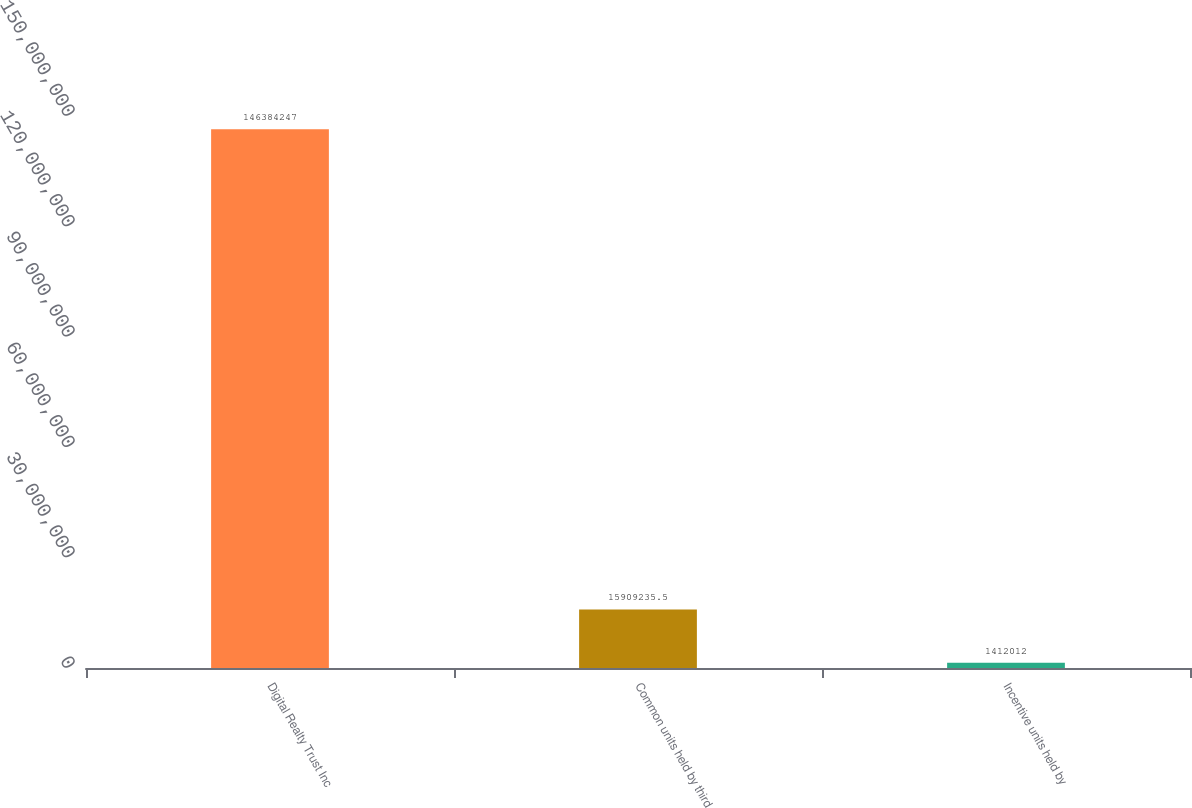<chart> <loc_0><loc_0><loc_500><loc_500><bar_chart><fcel>Digital Realty Trust Inc<fcel>Common units held by third<fcel>Incentive units held by<nl><fcel>1.46384e+08<fcel>1.59092e+07<fcel>1.41201e+06<nl></chart> 